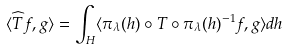Convert formula to latex. <formula><loc_0><loc_0><loc_500><loc_500>\langle \widehat { T } f , g \rangle = \int _ { H } \langle \pi _ { \lambda } ( h ) \circ T \circ \pi _ { \lambda } ( h ) ^ { - 1 } f , g \rangle d h</formula> 